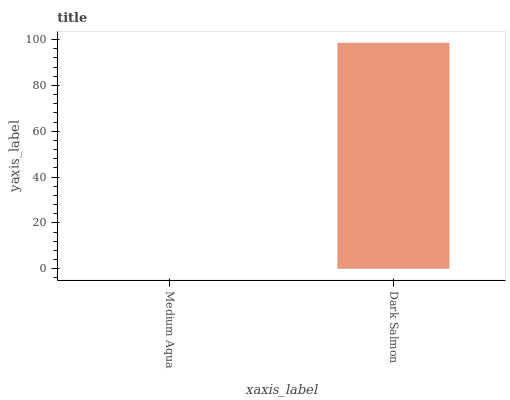Is Dark Salmon the minimum?
Answer yes or no. No. Is Dark Salmon greater than Medium Aqua?
Answer yes or no. Yes. Is Medium Aqua less than Dark Salmon?
Answer yes or no. Yes. Is Medium Aqua greater than Dark Salmon?
Answer yes or no. No. Is Dark Salmon less than Medium Aqua?
Answer yes or no. No. Is Dark Salmon the high median?
Answer yes or no. Yes. Is Medium Aqua the low median?
Answer yes or no. Yes. Is Medium Aqua the high median?
Answer yes or no. No. Is Dark Salmon the low median?
Answer yes or no. No. 